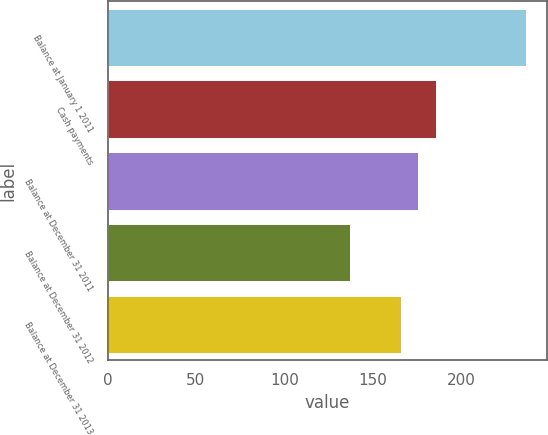<chart> <loc_0><loc_0><loc_500><loc_500><bar_chart><fcel>Balance at January 1 2011<fcel>Cash payments<fcel>Balance at December 31 2011<fcel>Balance at December 31 2012<fcel>Balance at December 31 2013<nl><fcel>237<fcel>186<fcel>176<fcel>137<fcel>166<nl></chart> 